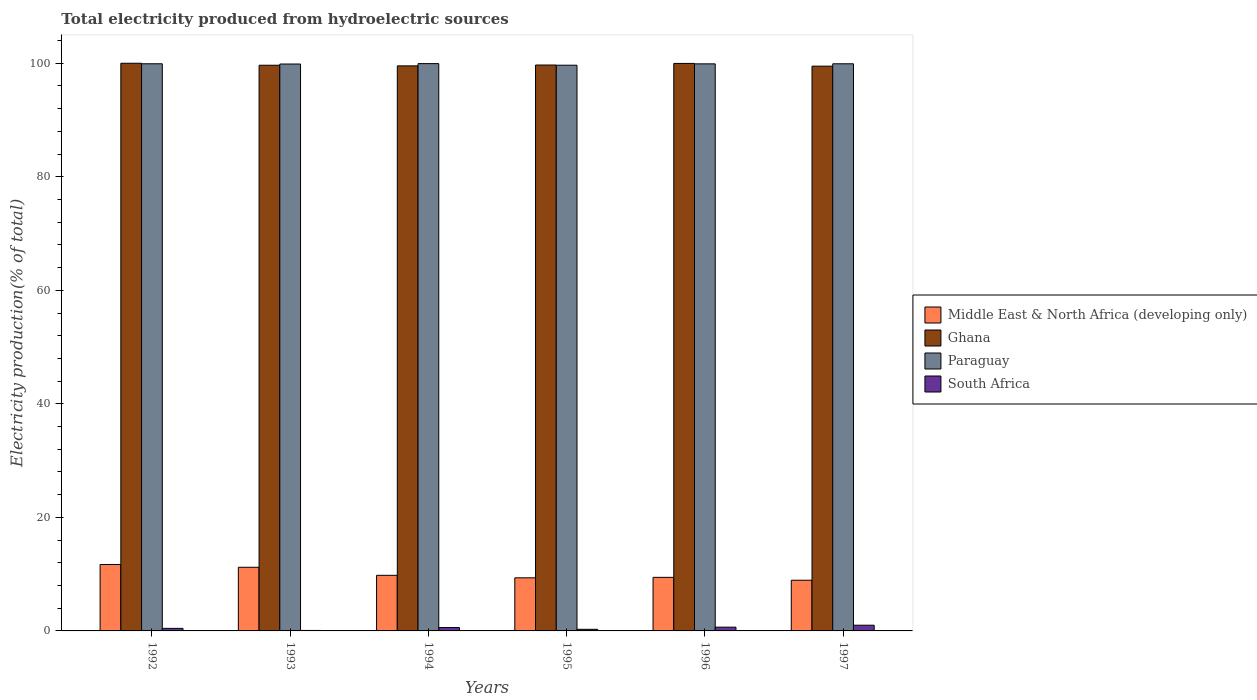How many groups of bars are there?
Offer a terse response. 6. What is the label of the 5th group of bars from the left?
Give a very brief answer. 1996. In how many cases, is the number of bars for a given year not equal to the number of legend labels?
Your answer should be compact. 0. What is the total electricity produced in Middle East & North Africa (developing only) in 1992?
Your response must be concise. 11.7. Across all years, what is the minimum total electricity produced in Ghana?
Provide a succinct answer. 99.49. What is the total total electricity produced in Ghana in the graph?
Your response must be concise. 598.34. What is the difference between the total electricity produced in South Africa in 1995 and that in 1997?
Your answer should be compact. -0.72. What is the difference between the total electricity produced in Middle East & North Africa (developing only) in 1997 and the total electricity produced in South Africa in 1994?
Ensure brevity in your answer.  8.34. What is the average total electricity produced in South Africa per year?
Your response must be concise. 0.51. In the year 1997, what is the difference between the total electricity produced in Paraguay and total electricity produced in Ghana?
Offer a very short reply. 0.42. In how many years, is the total electricity produced in Ghana greater than 92 %?
Your answer should be compact. 6. What is the ratio of the total electricity produced in South Africa in 1992 to that in 1996?
Provide a short and direct response. 0.68. Is the total electricity produced in Paraguay in 1992 less than that in 1994?
Keep it short and to the point. Yes. Is the difference between the total electricity produced in Paraguay in 1994 and 1995 greater than the difference between the total electricity produced in Ghana in 1994 and 1995?
Give a very brief answer. Yes. What is the difference between the highest and the second highest total electricity produced in South Africa?
Offer a very short reply. 0.35. What is the difference between the highest and the lowest total electricity produced in South Africa?
Give a very brief answer. 0.92. In how many years, is the total electricity produced in Paraguay greater than the average total electricity produced in Paraguay taken over all years?
Provide a short and direct response. 5. Is the sum of the total electricity produced in Ghana in 1994 and 1996 greater than the maximum total electricity produced in Middle East & North Africa (developing only) across all years?
Your answer should be compact. Yes. Is it the case that in every year, the sum of the total electricity produced in Ghana and total electricity produced in Middle East & North Africa (developing only) is greater than the sum of total electricity produced in Paraguay and total electricity produced in South Africa?
Your answer should be very brief. No. What does the 4th bar from the left in 1994 represents?
Provide a short and direct response. South Africa. What does the 1st bar from the right in 1992 represents?
Ensure brevity in your answer.  South Africa. Are all the bars in the graph horizontal?
Your answer should be very brief. No. How many years are there in the graph?
Your response must be concise. 6. Does the graph contain grids?
Offer a very short reply. No. What is the title of the graph?
Keep it short and to the point. Total electricity produced from hydroelectric sources. Does "Burundi" appear as one of the legend labels in the graph?
Make the answer very short. No. What is the label or title of the X-axis?
Your response must be concise. Years. What is the Electricity production(% of total) in Middle East & North Africa (developing only) in 1992?
Provide a succinct answer. 11.7. What is the Electricity production(% of total) of Paraguay in 1992?
Give a very brief answer. 99.91. What is the Electricity production(% of total) in South Africa in 1992?
Offer a very short reply. 0.45. What is the Electricity production(% of total) in Middle East & North Africa (developing only) in 1993?
Provide a succinct answer. 11.21. What is the Electricity production(% of total) in Ghana in 1993?
Keep it short and to the point. 99.65. What is the Electricity production(% of total) of Paraguay in 1993?
Give a very brief answer. 99.87. What is the Electricity production(% of total) of South Africa in 1993?
Offer a terse response. 0.08. What is the Electricity production(% of total) of Middle East & North Africa (developing only) in 1994?
Offer a very short reply. 9.79. What is the Electricity production(% of total) in Ghana in 1994?
Your answer should be very brief. 99.54. What is the Electricity production(% of total) in Paraguay in 1994?
Provide a succinct answer. 99.94. What is the Electricity production(% of total) in South Africa in 1994?
Give a very brief answer. 0.6. What is the Electricity production(% of total) of Middle East & North Africa (developing only) in 1995?
Your response must be concise. 9.35. What is the Electricity production(% of total) in Ghana in 1995?
Make the answer very short. 99.69. What is the Electricity production(% of total) of Paraguay in 1995?
Give a very brief answer. 99.66. What is the Electricity production(% of total) in South Africa in 1995?
Provide a short and direct response. 0.29. What is the Electricity production(% of total) in Middle East & North Africa (developing only) in 1996?
Offer a terse response. 9.44. What is the Electricity production(% of total) in Ghana in 1996?
Keep it short and to the point. 99.97. What is the Electricity production(% of total) of Paraguay in 1996?
Provide a succinct answer. 99.9. What is the Electricity production(% of total) in South Africa in 1996?
Keep it short and to the point. 0.66. What is the Electricity production(% of total) in Middle East & North Africa (developing only) in 1997?
Ensure brevity in your answer.  8.93. What is the Electricity production(% of total) in Ghana in 1997?
Give a very brief answer. 99.49. What is the Electricity production(% of total) in Paraguay in 1997?
Give a very brief answer. 99.91. What is the Electricity production(% of total) of South Africa in 1997?
Your response must be concise. 1.01. Across all years, what is the maximum Electricity production(% of total) in Middle East & North Africa (developing only)?
Offer a very short reply. 11.7. Across all years, what is the maximum Electricity production(% of total) of Paraguay?
Keep it short and to the point. 99.94. Across all years, what is the maximum Electricity production(% of total) in South Africa?
Provide a succinct answer. 1.01. Across all years, what is the minimum Electricity production(% of total) in Middle East & North Africa (developing only)?
Keep it short and to the point. 8.93. Across all years, what is the minimum Electricity production(% of total) in Ghana?
Your response must be concise. 99.49. Across all years, what is the minimum Electricity production(% of total) of Paraguay?
Provide a succinct answer. 99.66. Across all years, what is the minimum Electricity production(% of total) of South Africa?
Keep it short and to the point. 0.08. What is the total Electricity production(% of total) in Middle East & North Africa (developing only) in the graph?
Your response must be concise. 60.43. What is the total Electricity production(% of total) in Ghana in the graph?
Ensure brevity in your answer.  598.34. What is the total Electricity production(% of total) in Paraguay in the graph?
Offer a terse response. 599.17. What is the total Electricity production(% of total) of South Africa in the graph?
Provide a short and direct response. 3.08. What is the difference between the Electricity production(% of total) of Middle East & North Africa (developing only) in 1992 and that in 1993?
Ensure brevity in your answer.  0.49. What is the difference between the Electricity production(% of total) in Ghana in 1992 and that in 1993?
Provide a short and direct response. 0.35. What is the difference between the Electricity production(% of total) of Paraguay in 1992 and that in 1993?
Your response must be concise. 0.04. What is the difference between the Electricity production(% of total) of South Africa in 1992 and that in 1993?
Your answer should be compact. 0.37. What is the difference between the Electricity production(% of total) in Middle East & North Africa (developing only) in 1992 and that in 1994?
Ensure brevity in your answer.  1.91. What is the difference between the Electricity production(% of total) in Ghana in 1992 and that in 1994?
Offer a terse response. 0.46. What is the difference between the Electricity production(% of total) in Paraguay in 1992 and that in 1994?
Offer a terse response. -0.03. What is the difference between the Electricity production(% of total) of South Africa in 1992 and that in 1994?
Make the answer very short. -0.15. What is the difference between the Electricity production(% of total) in Middle East & North Africa (developing only) in 1992 and that in 1995?
Offer a terse response. 2.35. What is the difference between the Electricity production(% of total) of Ghana in 1992 and that in 1995?
Provide a short and direct response. 0.31. What is the difference between the Electricity production(% of total) of Paraguay in 1992 and that in 1995?
Provide a short and direct response. 0.25. What is the difference between the Electricity production(% of total) of South Africa in 1992 and that in 1995?
Provide a succinct answer. 0.17. What is the difference between the Electricity production(% of total) in Middle East & North Africa (developing only) in 1992 and that in 1996?
Give a very brief answer. 2.27. What is the difference between the Electricity production(% of total) of Ghana in 1992 and that in 1996?
Your response must be concise. 0.03. What is the difference between the Electricity production(% of total) of Paraguay in 1992 and that in 1996?
Keep it short and to the point. 0.01. What is the difference between the Electricity production(% of total) in South Africa in 1992 and that in 1996?
Offer a very short reply. -0.21. What is the difference between the Electricity production(% of total) of Middle East & North Africa (developing only) in 1992 and that in 1997?
Make the answer very short. 2.77. What is the difference between the Electricity production(% of total) of Ghana in 1992 and that in 1997?
Provide a short and direct response. 0.51. What is the difference between the Electricity production(% of total) in South Africa in 1992 and that in 1997?
Make the answer very short. -0.56. What is the difference between the Electricity production(% of total) of Middle East & North Africa (developing only) in 1993 and that in 1994?
Make the answer very short. 1.42. What is the difference between the Electricity production(% of total) of Ghana in 1993 and that in 1994?
Offer a very short reply. 0.11. What is the difference between the Electricity production(% of total) of Paraguay in 1993 and that in 1994?
Your answer should be very brief. -0.07. What is the difference between the Electricity production(% of total) of South Africa in 1993 and that in 1994?
Offer a very short reply. -0.51. What is the difference between the Electricity production(% of total) in Middle East & North Africa (developing only) in 1993 and that in 1995?
Give a very brief answer. 1.86. What is the difference between the Electricity production(% of total) of Ghana in 1993 and that in 1995?
Your answer should be very brief. -0.04. What is the difference between the Electricity production(% of total) in Paraguay in 1993 and that in 1995?
Keep it short and to the point. 0.21. What is the difference between the Electricity production(% of total) in South Africa in 1993 and that in 1995?
Offer a very short reply. -0.2. What is the difference between the Electricity production(% of total) in Middle East & North Africa (developing only) in 1993 and that in 1996?
Your answer should be compact. 1.78. What is the difference between the Electricity production(% of total) of Ghana in 1993 and that in 1996?
Your answer should be compact. -0.32. What is the difference between the Electricity production(% of total) in Paraguay in 1993 and that in 1996?
Your answer should be compact. -0.03. What is the difference between the Electricity production(% of total) of South Africa in 1993 and that in 1996?
Offer a terse response. -0.58. What is the difference between the Electricity production(% of total) of Middle East & North Africa (developing only) in 1993 and that in 1997?
Provide a short and direct response. 2.28. What is the difference between the Electricity production(% of total) in Ghana in 1993 and that in 1997?
Your answer should be compact. 0.16. What is the difference between the Electricity production(% of total) in Paraguay in 1993 and that in 1997?
Keep it short and to the point. -0.04. What is the difference between the Electricity production(% of total) of South Africa in 1993 and that in 1997?
Keep it short and to the point. -0.92. What is the difference between the Electricity production(% of total) of Middle East & North Africa (developing only) in 1994 and that in 1995?
Give a very brief answer. 0.44. What is the difference between the Electricity production(% of total) of Ghana in 1994 and that in 1995?
Provide a short and direct response. -0.15. What is the difference between the Electricity production(% of total) in Paraguay in 1994 and that in 1995?
Give a very brief answer. 0.28. What is the difference between the Electricity production(% of total) of South Africa in 1994 and that in 1995?
Provide a short and direct response. 0.31. What is the difference between the Electricity production(% of total) of Middle East & North Africa (developing only) in 1994 and that in 1996?
Your response must be concise. 0.36. What is the difference between the Electricity production(% of total) of Ghana in 1994 and that in 1996?
Your answer should be very brief. -0.43. What is the difference between the Electricity production(% of total) in Paraguay in 1994 and that in 1996?
Your answer should be very brief. 0.04. What is the difference between the Electricity production(% of total) in South Africa in 1994 and that in 1996?
Make the answer very short. -0.07. What is the difference between the Electricity production(% of total) in Middle East & North Africa (developing only) in 1994 and that in 1997?
Your response must be concise. 0.86. What is the difference between the Electricity production(% of total) in Ghana in 1994 and that in 1997?
Provide a succinct answer. 0.05. What is the difference between the Electricity production(% of total) in Paraguay in 1994 and that in 1997?
Your response must be concise. 0.03. What is the difference between the Electricity production(% of total) in South Africa in 1994 and that in 1997?
Provide a succinct answer. -0.41. What is the difference between the Electricity production(% of total) of Middle East & North Africa (developing only) in 1995 and that in 1996?
Make the answer very short. -0.08. What is the difference between the Electricity production(% of total) of Ghana in 1995 and that in 1996?
Ensure brevity in your answer.  -0.28. What is the difference between the Electricity production(% of total) in Paraguay in 1995 and that in 1996?
Provide a short and direct response. -0.24. What is the difference between the Electricity production(% of total) in South Africa in 1995 and that in 1996?
Ensure brevity in your answer.  -0.38. What is the difference between the Electricity production(% of total) in Middle East & North Africa (developing only) in 1995 and that in 1997?
Your answer should be compact. 0.42. What is the difference between the Electricity production(% of total) of Ghana in 1995 and that in 1997?
Offer a very short reply. 0.2. What is the difference between the Electricity production(% of total) in Paraguay in 1995 and that in 1997?
Your answer should be very brief. -0.25. What is the difference between the Electricity production(% of total) in South Africa in 1995 and that in 1997?
Offer a very short reply. -0.72. What is the difference between the Electricity production(% of total) of Middle East & North Africa (developing only) in 1996 and that in 1997?
Make the answer very short. 0.51. What is the difference between the Electricity production(% of total) in Ghana in 1996 and that in 1997?
Make the answer very short. 0.48. What is the difference between the Electricity production(% of total) of Paraguay in 1996 and that in 1997?
Make the answer very short. -0.01. What is the difference between the Electricity production(% of total) of South Africa in 1996 and that in 1997?
Give a very brief answer. -0.35. What is the difference between the Electricity production(% of total) in Middle East & North Africa (developing only) in 1992 and the Electricity production(% of total) in Ghana in 1993?
Provide a short and direct response. -87.95. What is the difference between the Electricity production(% of total) in Middle East & North Africa (developing only) in 1992 and the Electricity production(% of total) in Paraguay in 1993?
Provide a short and direct response. -88.16. What is the difference between the Electricity production(% of total) in Middle East & North Africa (developing only) in 1992 and the Electricity production(% of total) in South Africa in 1993?
Your answer should be very brief. 11.62. What is the difference between the Electricity production(% of total) of Ghana in 1992 and the Electricity production(% of total) of Paraguay in 1993?
Make the answer very short. 0.13. What is the difference between the Electricity production(% of total) in Ghana in 1992 and the Electricity production(% of total) in South Africa in 1993?
Your answer should be very brief. 99.92. What is the difference between the Electricity production(% of total) of Paraguay in 1992 and the Electricity production(% of total) of South Africa in 1993?
Your response must be concise. 99.82. What is the difference between the Electricity production(% of total) of Middle East & North Africa (developing only) in 1992 and the Electricity production(% of total) of Ghana in 1994?
Offer a very short reply. -87.84. What is the difference between the Electricity production(% of total) in Middle East & North Africa (developing only) in 1992 and the Electricity production(% of total) in Paraguay in 1994?
Your answer should be very brief. -88.23. What is the difference between the Electricity production(% of total) of Middle East & North Africa (developing only) in 1992 and the Electricity production(% of total) of South Africa in 1994?
Your response must be concise. 11.11. What is the difference between the Electricity production(% of total) of Ghana in 1992 and the Electricity production(% of total) of Paraguay in 1994?
Provide a short and direct response. 0.06. What is the difference between the Electricity production(% of total) in Ghana in 1992 and the Electricity production(% of total) in South Africa in 1994?
Provide a short and direct response. 99.4. What is the difference between the Electricity production(% of total) in Paraguay in 1992 and the Electricity production(% of total) in South Africa in 1994?
Make the answer very short. 99.31. What is the difference between the Electricity production(% of total) of Middle East & North Africa (developing only) in 1992 and the Electricity production(% of total) of Ghana in 1995?
Offer a very short reply. -87.99. What is the difference between the Electricity production(% of total) in Middle East & North Africa (developing only) in 1992 and the Electricity production(% of total) in Paraguay in 1995?
Provide a succinct answer. -87.95. What is the difference between the Electricity production(% of total) in Middle East & North Africa (developing only) in 1992 and the Electricity production(% of total) in South Africa in 1995?
Provide a succinct answer. 11.42. What is the difference between the Electricity production(% of total) in Ghana in 1992 and the Electricity production(% of total) in Paraguay in 1995?
Offer a terse response. 0.34. What is the difference between the Electricity production(% of total) in Ghana in 1992 and the Electricity production(% of total) in South Africa in 1995?
Keep it short and to the point. 99.71. What is the difference between the Electricity production(% of total) of Paraguay in 1992 and the Electricity production(% of total) of South Africa in 1995?
Offer a very short reply. 99.62. What is the difference between the Electricity production(% of total) of Middle East & North Africa (developing only) in 1992 and the Electricity production(% of total) of Ghana in 1996?
Your answer should be very brief. -88.27. What is the difference between the Electricity production(% of total) of Middle East & North Africa (developing only) in 1992 and the Electricity production(% of total) of Paraguay in 1996?
Provide a short and direct response. -88.19. What is the difference between the Electricity production(% of total) of Middle East & North Africa (developing only) in 1992 and the Electricity production(% of total) of South Africa in 1996?
Offer a very short reply. 11.04. What is the difference between the Electricity production(% of total) of Ghana in 1992 and the Electricity production(% of total) of Paraguay in 1996?
Keep it short and to the point. 0.1. What is the difference between the Electricity production(% of total) of Ghana in 1992 and the Electricity production(% of total) of South Africa in 1996?
Your response must be concise. 99.34. What is the difference between the Electricity production(% of total) in Paraguay in 1992 and the Electricity production(% of total) in South Africa in 1996?
Offer a terse response. 99.25. What is the difference between the Electricity production(% of total) in Middle East & North Africa (developing only) in 1992 and the Electricity production(% of total) in Ghana in 1997?
Make the answer very short. -87.79. What is the difference between the Electricity production(% of total) in Middle East & North Africa (developing only) in 1992 and the Electricity production(% of total) in Paraguay in 1997?
Offer a very short reply. -88.2. What is the difference between the Electricity production(% of total) in Middle East & North Africa (developing only) in 1992 and the Electricity production(% of total) in South Africa in 1997?
Provide a succinct answer. 10.7. What is the difference between the Electricity production(% of total) of Ghana in 1992 and the Electricity production(% of total) of Paraguay in 1997?
Offer a terse response. 0.09. What is the difference between the Electricity production(% of total) in Ghana in 1992 and the Electricity production(% of total) in South Africa in 1997?
Ensure brevity in your answer.  98.99. What is the difference between the Electricity production(% of total) in Paraguay in 1992 and the Electricity production(% of total) in South Africa in 1997?
Keep it short and to the point. 98.9. What is the difference between the Electricity production(% of total) in Middle East & North Africa (developing only) in 1993 and the Electricity production(% of total) in Ghana in 1994?
Provide a succinct answer. -88.33. What is the difference between the Electricity production(% of total) in Middle East & North Africa (developing only) in 1993 and the Electricity production(% of total) in Paraguay in 1994?
Your answer should be compact. -88.72. What is the difference between the Electricity production(% of total) of Middle East & North Africa (developing only) in 1993 and the Electricity production(% of total) of South Africa in 1994?
Your answer should be compact. 10.62. What is the difference between the Electricity production(% of total) of Ghana in 1993 and the Electricity production(% of total) of Paraguay in 1994?
Make the answer very short. -0.29. What is the difference between the Electricity production(% of total) in Ghana in 1993 and the Electricity production(% of total) in South Africa in 1994?
Offer a terse response. 99.06. What is the difference between the Electricity production(% of total) in Paraguay in 1993 and the Electricity production(% of total) in South Africa in 1994?
Offer a terse response. 99.27. What is the difference between the Electricity production(% of total) in Middle East & North Africa (developing only) in 1993 and the Electricity production(% of total) in Ghana in 1995?
Provide a short and direct response. -88.48. What is the difference between the Electricity production(% of total) in Middle East & North Africa (developing only) in 1993 and the Electricity production(% of total) in Paraguay in 1995?
Your answer should be compact. -88.44. What is the difference between the Electricity production(% of total) in Middle East & North Africa (developing only) in 1993 and the Electricity production(% of total) in South Africa in 1995?
Provide a short and direct response. 10.93. What is the difference between the Electricity production(% of total) in Ghana in 1993 and the Electricity production(% of total) in Paraguay in 1995?
Offer a very short reply. -0.01. What is the difference between the Electricity production(% of total) of Ghana in 1993 and the Electricity production(% of total) of South Africa in 1995?
Offer a very short reply. 99.37. What is the difference between the Electricity production(% of total) of Paraguay in 1993 and the Electricity production(% of total) of South Africa in 1995?
Keep it short and to the point. 99.58. What is the difference between the Electricity production(% of total) of Middle East & North Africa (developing only) in 1993 and the Electricity production(% of total) of Ghana in 1996?
Make the answer very short. -88.76. What is the difference between the Electricity production(% of total) of Middle East & North Africa (developing only) in 1993 and the Electricity production(% of total) of Paraguay in 1996?
Give a very brief answer. -88.68. What is the difference between the Electricity production(% of total) in Middle East & North Africa (developing only) in 1993 and the Electricity production(% of total) in South Africa in 1996?
Ensure brevity in your answer.  10.55. What is the difference between the Electricity production(% of total) of Ghana in 1993 and the Electricity production(% of total) of Paraguay in 1996?
Offer a very short reply. -0.24. What is the difference between the Electricity production(% of total) in Ghana in 1993 and the Electricity production(% of total) in South Africa in 1996?
Provide a short and direct response. 98.99. What is the difference between the Electricity production(% of total) of Paraguay in 1993 and the Electricity production(% of total) of South Africa in 1996?
Make the answer very short. 99.21. What is the difference between the Electricity production(% of total) in Middle East & North Africa (developing only) in 1993 and the Electricity production(% of total) in Ghana in 1997?
Your answer should be very brief. -88.28. What is the difference between the Electricity production(% of total) of Middle East & North Africa (developing only) in 1993 and the Electricity production(% of total) of Paraguay in 1997?
Ensure brevity in your answer.  -88.69. What is the difference between the Electricity production(% of total) of Middle East & North Africa (developing only) in 1993 and the Electricity production(% of total) of South Africa in 1997?
Keep it short and to the point. 10.21. What is the difference between the Electricity production(% of total) in Ghana in 1993 and the Electricity production(% of total) in Paraguay in 1997?
Your answer should be very brief. -0.26. What is the difference between the Electricity production(% of total) in Ghana in 1993 and the Electricity production(% of total) in South Africa in 1997?
Your answer should be compact. 98.64. What is the difference between the Electricity production(% of total) in Paraguay in 1993 and the Electricity production(% of total) in South Africa in 1997?
Make the answer very short. 98.86. What is the difference between the Electricity production(% of total) of Middle East & North Africa (developing only) in 1994 and the Electricity production(% of total) of Ghana in 1995?
Your answer should be very brief. -89.9. What is the difference between the Electricity production(% of total) of Middle East & North Africa (developing only) in 1994 and the Electricity production(% of total) of Paraguay in 1995?
Your answer should be compact. -89.86. What is the difference between the Electricity production(% of total) of Middle East & North Africa (developing only) in 1994 and the Electricity production(% of total) of South Africa in 1995?
Offer a terse response. 9.51. What is the difference between the Electricity production(% of total) of Ghana in 1994 and the Electricity production(% of total) of Paraguay in 1995?
Your answer should be very brief. -0.12. What is the difference between the Electricity production(% of total) of Ghana in 1994 and the Electricity production(% of total) of South Africa in 1995?
Make the answer very short. 99.26. What is the difference between the Electricity production(% of total) of Paraguay in 1994 and the Electricity production(% of total) of South Africa in 1995?
Make the answer very short. 99.65. What is the difference between the Electricity production(% of total) in Middle East & North Africa (developing only) in 1994 and the Electricity production(% of total) in Ghana in 1996?
Your answer should be compact. -90.18. What is the difference between the Electricity production(% of total) in Middle East & North Africa (developing only) in 1994 and the Electricity production(% of total) in Paraguay in 1996?
Offer a terse response. -90.1. What is the difference between the Electricity production(% of total) of Middle East & North Africa (developing only) in 1994 and the Electricity production(% of total) of South Africa in 1996?
Your answer should be compact. 9.13. What is the difference between the Electricity production(% of total) of Ghana in 1994 and the Electricity production(% of total) of Paraguay in 1996?
Make the answer very short. -0.35. What is the difference between the Electricity production(% of total) of Ghana in 1994 and the Electricity production(% of total) of South Africa in 1996?
Your answer should be compact. 98.88. What is the difference between the Electricity production(% of total) of Paraguay in 1994 and the Electricity production(% of total) of South Africa in 1996?
Give a very brief answer. 99.28. What is the difference between the Electricity production(% of total) in Middle East & North Africa (developing only) in 1994 and the Electricity production(% of total) in Ghana in 1997?
Your response must be concise. -89.7. What is the difference between the Electricity production(% of total) in Middle East & North Africa (developing only) in 1994 and the Electricity production(% of total) in Paraguay in 1997?
Your answer should be very brief. -90.11. What is the difference between the Electricity production(% of total) in Middle East & North Africa (developing only) in 1994 and the Electricity production(% of total) in South Africa in 1997?
Offer a very short reply. 8.79. What is the difference between the Electricity production(% of total) of Ghana in 1994 and the Electricity production(% of total) of Paraguay in 1997?
Make the answer very short. -0.37. What is the difference between the Electricity production(% of total) in Ghana in 1994 and the Electricity production(% of total) in South Africa in 1997?
Ensure brevity in your answer.  98.53. What is the difference between the Electricity production(% of total) of Paraguay in 1994 and the Electricity production(% of total) of South Africa in 1997?
Keep it short and to the point. 98.93. What is the difference between the Electricity production(% of total) of Middle East & North Africa (developing only) in 1995 and the Electricity production(% of total) of Ghana in 1996?
Make the answer very short. -90.62. What is the difference between the Electricity production(% of total) of Middle East & North Africa (developing only) in 1995 and the Electricity production(% of total) of Paraguay in 1996?
Your answer should be compact. -90.54. What is the difference between the Electricity production(% of total) in Middle East & North Africa (developing only) in 1995 and the Electricity production(% of total) in South Africa in 1996?
Your answer should be very brief. 8.69. What is the difference between the Electricity production(% of total) in Ghana in 1995 and the Electricity production(% of total) in Paraguay in 1996?
Offer a very short reply. -0.21. What is the difference between the Electricity production(% of total) of Ghana in 1995 and the Electricity production(% of total) of South Africa in 1996?
Give a very brief answer. 99.03. What is the difference between the Electricity production(% of total) in Paraguay in 1995 and the Electricity production(% of total) in South Africa in 1996?
Make the answer very short. 99. What is the difference between the Electricity production(% of total) of Middle East & North Africa (developing only) in 1995 and the Electricity production(% of total) of Ghana in 1997?
Make the answer very short. -90.14. What is the difference between the Electricity production(% of total) of Middle East & North Africa (developing only) in 1995 and the Electricity production(% of total) of Paraguay in 1997?
Give a very brief answer. -90.55. What is the difference between the Electricity production(% of total) of Middle East & North Africa (developing only) in 1995 and the Electricity production(% of total) of South Africa in 1997?
Keep it short and to the point. 8.35. What is the difference between the Electricity production(% of total) of Ghana in 1995 and the Electricity production(% of total) of Paraguay in 1997?
Make the answer very short. -0.22. What is the difference between the Electricity production(% of total) of Ghana in 1995 and the Electricity production(% of total) of South Africa in 1997?
Provide a succinct answer. 98.68. What is the difference between the Electricity production(% of total) in Paraguay in 1995 and the Electricity production(% of total) in South Africa in 1997?
Keep it short and to the point. 98.65. What is the difference between the Electricity production(% of total) in Middle East & North Africa (developing only) in 1996 and the Electricity production(% of total) in Ghana in 1997?
Your answer should be compact. -90.05. What is the difference between the Electricity production(% of total) in Middle East & North Africa (developing only) in 1996 and the Electricity production(% of total) in Paraguay in 1997?
Provide a short and direct response. -90.47. What is the difference between the Electricity production(% of total) of Middle East & North Africa (developing only) in 1996 and the Electricity production(% of total) of South Africa in 1997?
Your response must be concise. 8.43. What is the difference between the Electricity production(% of total) in Ghana in 1996 and the Electricity production(% of total) in Paraguay in 1997?
Give a very brief answer. 0.06. What is the difference between the Electricity production(% of total) in Ghana in 1996 and the Electricity production(% of total) in South Africa in 1997?
Keep it short and to the point. 98.96. What is the difference between the Electricity production(% of total) of Paraguay in 1996 and the Electricity production(% of total) of South Africa in 1997?
Your answer should be compact. 98.89. What is the average Electricity production(% of total) of Middle East & North Africa (developing only) per year?
Give a very brief answer. 10.07. What is the average Electricity production(% of total) of Ghana per year?
Provide a succinct answer. 99.72. What is the average Electricity production(% of total) of Paraguay per year?
Provide a succinct answer. 99.86. What is the average Electricity production(% of total) of South Africa per year?
Keep it short and to the point. 0.51. In the year 1992, what is the difference between the Electricity production(% of total) in Middle East & North Africa (developing only) and Electricity production(% of total) in Ghana?
Give a very brief answer. -88.3. In the year 1992, what is the difference between the Electricity production(% of total) of Middle East & North Africa (developing only) and Electricity production(% of total) of Paraguay?
Give a very brief answer. -88.2. In the year 1992, what is the difference between the Electricity production(% of total) in Middle East & North Africa (developing only) and Electricity production(% of total) in South Africa?
Ensure brevity in your answer.  11.25. In the year 1992, what is the difference between the Electricity production(% of total) of Ghana and Electricity production(% of total) of Paraguay?
Make the answer very short. 0.09. In the year 1992, what is the difference between the Electricity production(% of total) in Ghana and Electricity production(% of total) in South Africa?
Provide a short and direct response. 99.55. In the year 1992, what is the difference between the Electricity production(% of total) of Paraguay and Electricity production(% of total) of South Africa?
Your answer should be compact. 99.46. In the year 1993, what is the difference between the Electricity production(% of total) in Middle East & North Africa (developing only) and Electricity production(% of total) in Ghana?
Your response must be concise. -88.44. In the year 1993, what is the difference between the Electricity production(% of total) in Middle East & North Africa (developing only) and Electricity production(% of total) in Paraguay?
Offer a very short reply. -88.65. In the year 1993, what is the difference between the Electricity production(% of total) in Middle East & North Africa (developing only) and Electricity production(% of total) in South Africa?
Give a very brief answer. 11.13. In the year 1993, what is the difference between the Electricity production(% of total) of Ghana and Electricity production(% of total) of Paraguay?
Provide a short and direct response. -0.21. In the year 1993, what is the difference between the Electricity production(% of total) in Ghana and Electricity production(% of total) in South Africa?
Offer a very short reply. 99.57. In the year 1993, what is the difference between the Electricity production(% of total) in Paraguay and Electricity production(% of total) in South Africa?
Provide a short and direct response. 99.78. In the year 1994, what is the difference between the Electricity production(% of total) in Middle East & North Africa (developing only) and Electricity production(% of total) in Ghana?
Make the answer very short. -89.75. In the year 1994, what is the difference between the Electricity production(% of total) of Middle East & North Africa (developing only) and Electricity production(% of total) of Paraguay?
Your response must be concise. -90.14. In the year 1994, what is the difference between the Electricity production(% of total) in Middle East & North Africa (developing only) and Electricity production(% of total) in South Africa?
Your answer should be very brief. 9.2. In the year 1994, what is the difference between the Electricity production(% of total) in Ghana and Electricity production(% of total) in Paraguay?
Offer a terse response. -0.4. In the year 1994, what is the difference between the Electricity production(% of total) in Ghana and Electricity production(% of total) in South Africa?
Provide a short and direct response. 98.95. In the year 1994, what is the difference between the Electricity production(% of total) of Paraguay and Electricity production(% of total) of South Africa?
Offer a very short reply. 99.34. In the year 1995, what is the difference between the Electricity production(% of total) in Middle East & North Africa (developing only) and Electricity production(% of total) in Ghana?
Ensure brevity in your answer.  -90.34. In the year 1995, what is the difference between the Electricity production(% of total) of Middle East & North Africa (developing only) and Electricity production(% of total) of Paraguay?
Offer a terse response. -90.3. In the year 1995, what is the difference between the Electricity production(% of total) of Middle East & North Africa (developing only) and Electricity production(% of total) of South Africa?
Your response must be concise. 9.07. In the year 1995, what is the difference between the Electricity production(% of total) of Ghana and Electricity production(% of total) of Paraguay?
Offer a very short reply. 0.03. In the year 1995, what is the difference between the Electricity production(% of total) of Ghana and Electricity production(% of total) of South Africa?
Provide a succinct answer. 99.4. In the year 1995, what is the difference between the Electricity production(% of total) in Paraguay and Electricity production(% of total) in South Africa?
Your answer should be compact. 99.37. In the year 1996, what is the difference between the Electricity production(% of total) of Middle East & North Africa (developing only) and Electricity production(% of total) of Ghana?
Keep it short and to the point. -90.53. In the year 1996, what is the difference between the Electricity production(% of total) in Middle East & North Africa (developing only) and Electricity production(% of total) in Paraguay?
Provide a short and direct response. -90.46. In the year 1996, what is the difference between the Electricity production(% of total) of Middle East & North Africa (developing only) and Electricity production(% of total) of South Africa?
Give a very brief answer. 8.78. In the year 1996, what is the difference between the Electricity production(% of total) in Ghana and Electricity production(% of total) in Paraguay?
Offer a very short reply. 0.07. In the year 1996, what is the difference between the Electricity production(% of total) in Ghana and Electricity production(% of total) in South Africa?
Your answer should be compact. 99.31. In the year 1996, what is the difference between the Electricity production(% of total) of Paraguay and Electricity production(% of total) of South Africa?
Keep it short and to the point. 99.23. In the year 1997, what is the difference between the Electricity production(% of total) of Middle East & North Africa (developing only) and Electricity production(% of total) of Ghana?
Make the answer very short. -90.56. In the year 1997, what is the difference between the Electricity production(% of total) of Middle East & North Africa (developing only) and Electricity production(% of total) of Paraguay?
Keep it short and to the point. -90.98. In the year 1997, what is the difference between the Electricity production(% of total) of Middle East & North Africa (developing only) and Electricity production(% of total) of South Africa?
Your answer should be very brief. 7.92. In the year 1997, what is the difference between the Electricity production(% of total) in Ghana and Electricity production(% of total) in Paraguay?
Your answer should be compact. -0.42. In the year 1997, what is the difference between the Electricity production(% of total) in Ghana and Electricity production(% of total) in South Africa?
Give a very brief answer. 98.48. In the year 1997, what is the difference between the Electricity production(% of total) in Paraguay and Electricity production(% of total) in South Africa?
Offer a very short reply. 98.9. What is the ratio of the Electricity production(% of total) in Middle East & North Africa (developing only) in 1992 to that in 1993?
Your response must be concise. 1.04. What is the ratio of the Electricity production(% of total) in Ghana in 1992 to that in 1993?
Give a very brief answer. 1. What is the ratio of the Electricity production(% of total) of Paraguay in 1992 to that in 1993?
Provide a succinct answer. 1. What is the ratio of the Electricity production(% of total) in South Africa in 1992 to that in 1993?
Provide a succinct answer. 5.35. What is the ratio of the Electricity production(% of total) of Middle East & North Africa (developing only) in 1992 to that in 1994?
Provide a short and direct response. 1.19. What is the ratio of the Electricity production(% of total) in Ghana in 1992 to that in 1994?
Your answer should be very brief. 1. What is the ratio of the Electricity production(% of total) of South Africa in 1992 to that in 1994?
Offer a terse response. 0.76. What is the ratio of the Electricity production(% of total) in Middle East & North Africa (developing only) in 1992 to that in 1995?
Ensure brevity in your answer.  1.25. What is the ratio of the Electricity production(% of total) of South Africa in 1992 to that in 1995?
Offer a terse response. 1.58. What is the ratio of the Electricity production(% of total) of Middle East & North Africa (developing only) in 1992 to that in 1996?
Provide a short and direct response. 1.24. What is the ratio of the Electricity production(% of total) in Paraguay in 1992 to that in 1996?
Offer a terse response. 1. What is the ratio of the Electricity production(% of total) of South Africa in 1992 to that in 1996?
Offer a very short reply. 0.68. What is the ratio of the Electricity production(% of total) in Middle East & North Africa (developing only) in 1992 to that in 1997?
Offer a terse response. 1.31. What is the ratio of the Electricity production(% of total) of Ghana in 1992 to that in 1997?
Offer a very short reply. 1.01. What is the ratio of the Electricity production(% of total) of Paraguay in 1992 to that in 1997?
Your answer should be compact. 1. What is the ratio of the Electricity production(% of total) in South Africa in 1992 to that in 1997?
Your answer should be very brief. 0.45. What is the ratio of the Electricity production(% of total) in Middle East & North Africa (developing only) in 1993 to that in 1994?
Give a very brief answer. 1.14. What is the ratio of the Electricity production(% of total) of Ghana in 1993 to that in 1994?
Offer a terse response. 1. What is the ratio of the Electricity production(% of total) of Paraguay in 1993 to that in 1994?
Your answer should be compact. 1. What is the ratio of the Electricity production(% of total) in South Africa in 1993 to that in 1994?
Offer a terse response. 0.14. What is the ratio of the Electricity production(% of total) in Middle East & North Africa (developing only) in 1993 to that in 1995?
Keep it short and to the point. 1.2. What is the ratio of the Electricity production(% of total) of Ghana in 1993 to that in 1995?
Your answer should be very brief. 1. What is the ratio of the Electricity production(% of total) in South Africa in 1993 to that in 1995?
Offer a very short reply. 0.3. What is the ratio of the Electricity production(% of total) of Middle East & North Africa (developing only) in 1993 to that in 1996?
Provide a short and direct response. 1.19. What is the ratio of the Electricity production(% of total) in Paraguay in 1993 to that in 1996?
Offer a very short reply. 1. What is the ratio of the Electricity production(% of total) in South Africa in 1993 to that in 1996?
Your answer should be compact. 0.13. What is the ratio of the Electricity production(% of total) in Middle East & North Africa (developing only) in 1993 to that in 1997?
Offer a terse response. 1.26. What is the ratio of the Electricity production(% of total) in Ghana in 1993 to that in 1997?
Your response must be concise. 1. What is the ratio of the Electricity production(% of total) in Paraguay in 1993 to that in 1997?
Ensure brevity in your answer.  1. What is the ratio of the Electricity production(% of total) of South Africa in 1993 to that in 1997?
Offer a terse response. 0.08. What is the ratio of the Electricity production(% of total) in Middle East & North Africa (developing only) in 1994 to that in 1995?
Make the answer very short. 1.05. What is the ratio of the Electricity production(% of total) in Ghana in 1994 to that in 1995?
Your answer should be compact. 1. What is the ratio of the Electricity production(% of total) in South Africa in 1994 to that in 1995?
Offer a terse response. 2.09. What is the ratio of the Electricity production(% of total) in Middle East & North Africa (developing only) in 1994 to that in 1996?
Keep it short and to the point. 1.04. What is the ratio of the Electricity production(% of total) of Ghana in 1994 to that in 1996?
Offer a terse response. 1. What is the ratio of the Electricity production(% of total) in South Africa in 1994 to that in 1996?
Provide a succinct answer. 0.9. What is the ratio of the Electricity production(% of total) in Middle East & North Africa (developing only) in 1994 to that in 1997?
Your response must be concise. 1.1. What is the ratio of the Electricity production(% of total) in Ghana in 1994 to that in 1997?
Offer a very short reply. 1. What is the ratio of the Electricity production(% of total) in South Africa in 1994 to that in 1997?
Offer a very short reply. 0.59. What is the ratio of the Electricity production(% of total) of Ghana in 1995 to that in 1996?
Give a very brief answer. 1. What is the ratio of the Electricity production(% of total) in South Africa in 1995 to that in 1996?
Offer a very short reply. 0.43. What is the ratio of the Electricity production(% of total) of Middle East & North Africa (developing only) in 1995 to that in 1997?
Your answer should be very brief. 1.05. What is the ratio of the Electricity production(% of total) of South Africa in 1995 to that in 1997?
Give a very brief answer. 0.28. What is the ratio of the Electricity production(% of total) of Middle East & North Africa (developing only) in 1996 to that in 1997?
Your response must be concise. 1.06. What is the ratio of the Electricity production(% of total) in Ghana in 1996 to that in 1997?
Provide a short and direct response. 1. What is the ratio of the Electricity production(% of total) in Paraguay in 1996 to that in 1997?
Give a very brief answer. 1. What is the ratio of the Electricity production(% of total) in South Africa in 1996 to that in 1997?
Your answer should be very brief. 0.66. What is the difference between the highest and the second highest Electricity production(% of total) in Middle East & North Africa (developing only)?
Offer a terse response. 0.49. What is the difference between the highest and the second highest Electricity production(% of total) in Ghana?
Make the answer very short. 0.03. What is the difference between the highest and the second highest Electricity production(% of total) in Paraguay?
Provide a short and direct response. 0.03. What is the difference between the highest and the second highest Electricity production(% of total) in South Africa?
Offer a terse response. 0.35. What is the difference between the highest and the lowest Electricity production(% of total) in Middle East & North Africa (developing only)?
Keep it short and to the point. 2.77. What is the difference between the highest and the lowest Electricity production(% of total) of Ghana?
Keep it short and to the point. 0.51. What is the difference between the highest and the lowest Electricity production(% of total) in Paraguay?
Your answer should be compact. 0.28. What is the difference between the highest and the lowest Electricity production(% of total) of South Africa?
Keep it short and to the point. 0.92. 